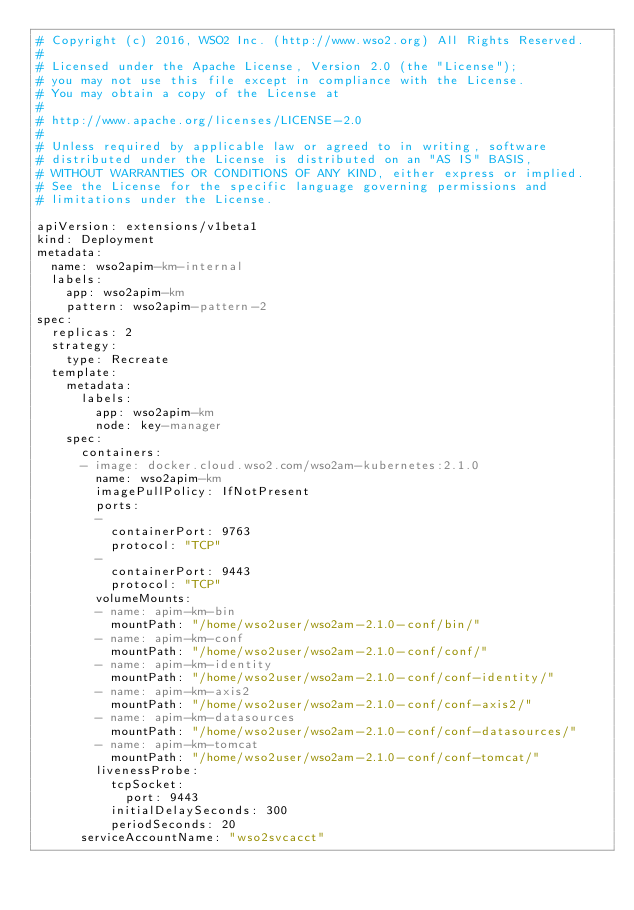Convert code to text. <code><loc_0><loc_0><loc_500><loc_500><_YAML_># Copyright (c) 2016, WSO2 Inc. (http://www.wso2.org) All Rights Reserved.
#
# Licensed under the Apache License, Version 2.0 (the "License");
# you may not use this file except in compliance with the License.
# You may obtain a copy of the License at
#
# http://www.apache.org/licenses/LICENSE-2.0
#
# Unless required by applicable law or agreed to in writing, software
# distributed under the License is distributed on an "AS IS" BASIS,
# WITHOUT WARRANTIES OR CONDITIONS OF ANY KIND, either express or implied.
# See the License for the specific language governing permissions and
# limitations under the License.

apiVersion: extensions/v1beta1
kind: Deployment
metadata:
  name: wso2apim-km-internal
  labels:
    app: wso2apim-km
    pattern: wso2apim-pattern-2
spec:
  replicas: 2
  strategy:
    type: Recreate
  template:
    metadata:
      labels:
        app: wso2apim-km
        node: key-manager
    spec:
      containers:
      - image: docker.cloud.wso2.com/wso2am-kubernetes:2.1.0
        name: wso2apim-km
        imagePullPolicy: IfNotPresent
        ports:
        -
          containerPort: 9763
          protocol: "TCP"
        -
          containerPort: 9443
          protocol: "TCP"
        volumeMounts:
        - name: apim-km-bin
          mountPath: "/home/wso2user/wso2am-2.1.0-conf/bin/"
        - name: apim-km-conf
          mountPath: "/home/wso2user/wso2am-2.1.0-conf/conf/"
        - name: apim-km-identity
          mountPath: "/home/wso2user/wso2am-2.1.0-conf/conf-identity/"
        - name: apim-km-axis2
          mountPath: "/home/wso2user/wso2am-2.1.0-conf/conf-axis2/"
        - name: apim-km-datasources
          mountPath: "/home/wso2user/wso2am-2.1.0-conf/conf-datasources/"
        - name: apim-km-tomcat
          mountPath: "/home/wso2user/wso2am-2.1.0-conf/conf-tomcat/"
        livenessProbe:
          tcpSocket:
            port: 9443
          initialDelaySeconds: 300
          periodSeconds: 20
      serviceAccountName: "wso2svcacct"</code> 